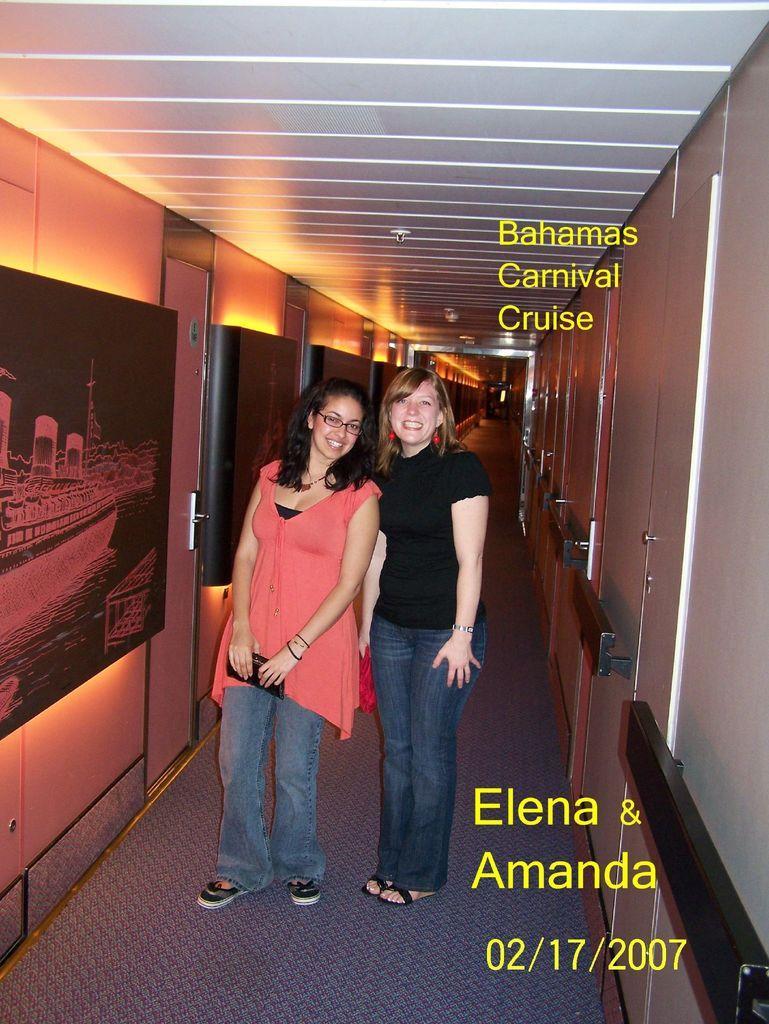How would you summarize this image in a sentence or two? In this image we can see two women are standing on the floor and they are smiling. Here we can see wall, doors, ceiling, lights, and a frame. Here we can see something is written on it. 